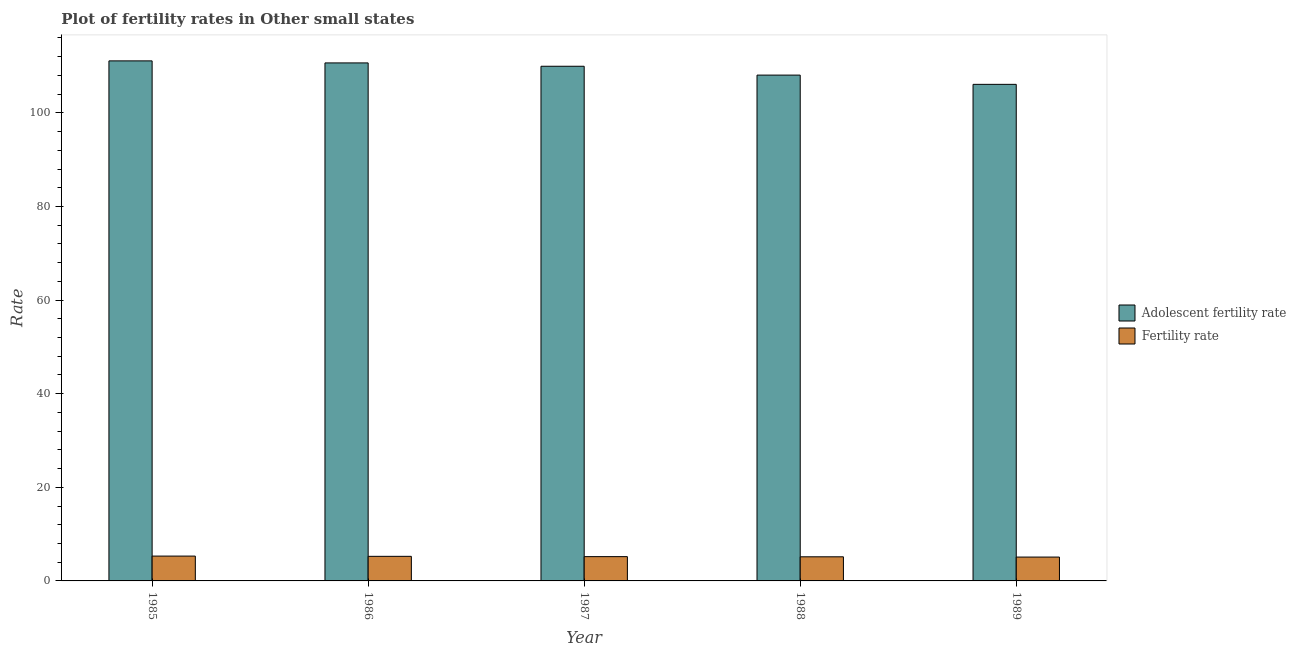How many different coloured bars are there?
Provide a succinct answer. 2. How many groups of bars are there?
Your response must be concise. 5. Are the number of bars on each tick of the X-axis equal?
Give a very brief answer. Yes. What is the label of the 1st group of bars from the left?
Your answer should be very brief. 1985. In how many cases, is the number of bars for a given year not equal to the number of legend labels?
Give a very brief answer. 0. What is the fertility rate in 1987?
Offer a very short reply. 5.19. Across all years, what is the maximum fertility rate?
Give a very brief answer. 5.3. Across all years, what is the minimum adolescent fertility rate?
Keep it short and to the point. 106.08. What is the total adolescent fertility rate in the graph?
Your answer should be very brief. 545.86. What is the difference between the fertility rate in 1986 and that in 1987?
Provide a succinct answer. 0.06. What is the difference between the fertility rate in 1988 and the adolescent fertility rate in 1989?
Ensure brevity in your answer.  0.06. What is the average adolescent fertility rate per year?
Provide a short and direct response. 109.17. In how many years, is the adolescent fertility rate greater than 60?
Keep it short and to the point. 5. What is the ratio of the fertility rate in 1987 to that in 1989?
Provide a succinct answer. 1.02. Is the adolescent fertility rate in 1987 less than that in 1988?
Offer a terse response. No. Is the difference between the fertility rate in 1986 and 1987 greater than the difference between the adolescent fertility rate in 1986 and 1987?
Make the answer very short. No. What is the difference between the highest and the second highest adolescent fertility rate?
Your answer should be very brief. 0.44. What is the difference between the highest and the lowest adolescent fertility rate?
Offer a very short reply. 5.02. In how many years, is the fertility rate greater than the average fertility rate taken over all years?
Offer a terse response. 2. Is the sum of the fertility rate in 1987 and 1988 greater than the maximum adolescent fertility rate across all years?
Provide a short and direct response. Yes. What does the 1st bar from the left in 1988 represents?
Keep it short and to the point. Adolescent fertility rate. What does the 1st bar from the right in 1988 represents?
Give a very brief answer. Fertility rate. How many bars are there?
Ensure brevity in your answer.  10. What is the difference between two consecutive major ticks on the Y-axis?
Offer a terse response. 20. Are the values on the major ticks of Y-axis written in scientific E-notation?
Your answer should be compact. No. What is the title of the graph?
Keep it short and to the point. Plot of fertility rates in Other small states. What is the label or title of the X-axis?
Keep it short and to the point. Year. What is the label or title of the Y-axis?
Give a very brief answer. Rate. What is the Rate of Adolescent fertility rate in 1985?
Your response must be concise. 111.1. What is the Rate of Fertility rate in 1985?
Ensure brevity in your answer.  5.3. What is the Rate of Adolescent fertility rate in 1986?
Make the answer very short. 110.66. What is the Rate of Fertility rate in 1986?
Your answer should be compact. 5.25. What is the Rate in Adolescent fertility rate in 1987?
Your answer should be compact. 109.95. What is the Rate in Fertility rate in 1987?
Offer a very short reply. 5.19. What is the Rate in Adolescent fertility rate in 1988?
Provide a succinct answer. 108.06. What is the Rate in Fertility rate in 1988?
Keep it short and to the point. 5.15. What is the Rate of Adolescent fertility rate in 1989?
Provide a short and direct response. 106.08. What is the Rate in Fertility rate in 1989?
Offer a very short reply. 5.1. Across all years, what is the maximum Rate in Adolescent fertility rate?
Ensure brevity in your answer.  111.1. Across all years, what is the maximum Rate in Fertility rate?
Provide a succinct answer. 5.3. Across all years, what is the minimum Rate in Adolescent fertility rate?
Offer a very short reply. 106.08. Across all years, what is the minimum Rate of Fertility rate?
Make the answer very short. 5.1. What is the total Rate of Adolescent fertility rate in the graph?
Keep it short and to the point. 545.86. What is the total Rate of Fertility rate in the graph?
Your response must be concise. 25.99. What is the difference between the Rate of Adolescent fertility rate in 1985 and that in 1986?
Ensure brevity in your answer.  0.44. What is the difference between the Rate in Fertility rate in 1985 and that in 1986?
Give a very brief answer. 0.05. What is the difference between the Rate of Adolescent fertility rate in 1985 and that in 1987?
Provide a succinct answer. 1.15. What is the difference between the Rate in Fertility rate in 1985 and that in 1987?
Offer a very short reply. 0.11. What is the difference between the Rate of Adolescent fertility rate in 1985 and that in 1988?
Give a very brief answer. 3.04. What is the difference between the Rate in Fertility rate in 1985 and that in 1988?
Make the answer very short. 0.15. What is the difference between the Rate in Adolescent fertility rate in 1985 and that in 1989?
Offer a very short reply. 5.02. What is the difference between the Rate of Fertility rate in 1985 and that in 1989?
Your response must be concise. 0.21. What is the difference between the Rate in Adolescent fertility rate in 1986 and that in 1987?
Give a very brief answer. 0.71. What is the difference between the Rate in Fertility rate in 1986 and that in 1987?
Keep it short and to the point. 0.06. What is the difference between the Rate of Adolescent fertility rate in 1986 and that in 1988?
Your response must be concise. 2.6. What is the difference between the Rate in Fertility rate in 1986 and that in 1988?
Make the answer very short. 0.1. What is the difference between the Rate in Adolescent fertility rate in 1986 and that in 1989?
Ensure brevity in your answer.  4.58. What is the difference between the Rate in Fertility rate in 1986 and that in 1989?
Your answer should be compact. 0.16. What is the difference between the Rate of Adolescent fertility rate in 1987 and that in 1988?
Keep it short and to the point. 1.89. What is the difference between the Rate in Fertility rate in 1987 and that in 1988?
Your answer should be compact. 0.04. What is the difference between the Rate in Adolescent fertility rate in 1987 and that in 1989?
Ensure brevity in your answer.  3.87. What is the difference between the Rate of Fertility rate in 1987 and that in 1989?
Give a very brief answer. 0.09. What is the difference between the Rate in Adolescent fertility rate in 1988 and that in 1989?
Offer a very short reply. 1.98. What is the difference between the Rate of Fertility rate in 1988 and that in 1989?
Your answer should be compact. 0.06. What is the difference between the Rate in Adolescent fertility rate in 1985 and the Rate in Fertility rate in 1986?
Offer a very short reply. 105.85. What is the difference between the Rate in Adolescent fertility rate in 1985 and the Rate in Fertility rate in 1987?
Your response must be concise. 105.91. What is the difference between the Rate in Adolescent fertility rate in 1985 and the Rate in Fertility rate in 1988?
Ensure brevity in your answer.  105.95. What is the difference between the Rate in Adolescent fertility rate in 1985 and the Rate in Fertility rate in 1989?
Provide a succinct answer. 106. What is the difference between the Rate of Adolescent fertility rate in 1986 and the Rate of Fertility rate in 1987?
Your answer should be compact. 105.47. What is the difference between the Rate in Adolescent fertility rate in 1986 and the Rate in Fertility rate in 1988?
Your answer should be compact. 105.51. What is the difference between the Rate of Adolescent fertility rate in 1986 and the Rate of Fertility rate in 1989?
Give a very brief answer. 105.57. What is the difference between the Rate in Adolescent fertility rate in 1987 and the Rate in Fertility rate in 1988?
Provide a short and direct response. 104.8. What is the difference between the Rate in Adolescent fertility rate in 1987 and the Rate in Fertility rate in 1989?
Offer a terse response. 104.86. What is the difference between the Rate in Adolescent fertility rate in 1988 and the Rate in Fertility rate in 1989?
Your response must be concise. 102.97. What is the average Rate of Adolescent fertility rate per year?
Ensure brevity in your answer.  109.17. What is the average Rate of Fertility rate per year?
Offer a very short reply. 5.2. In the year 1985, what is the difference between the Rate in Adolescent fertility rate and Rate in Fertility rate?
Offer a terse response. 105.8. In the year 1986, what is the difference between the Rate of Adolescent fertility rate and Rate of Fertility rate?
Your response must be concise. 105.41. In the year 1987, what is the difference between the Rate in Adolescent fertility rate and Rate in Fertility rate?
Give a very brief answer. 104.76. In the year 1988, what is the difference between the Rate of Adolescent fertility rate and Rate of Fertility rate?
Make the answer very short. 102.91. In the year 1989, what is the difference between the Rate of Adolescent fertility rate and Rate of Fertility rate?
Ensure brevity in your answer.  100.99. What is the ratio of the Rate in Fertility rate in 1985 to that in 1986?
Your answer should be compact. 1.01. What is the ratio of the Rate of Adolescent fertility rate in 1985 to that in 1987?
Make the answer very short. 1.01. What is the ratio of the Rate in Fertility rate in 1985 to that in 1987?
Give a very brief answer. 1.02. What is the ratio of the Rate in Adolescent fertility rate in 1985 to that in 1988?
Make the answer very short. 1.03. What is the ratio of the Rate of Fertility rate in 1985 to that in 1988?
Give a very brief answer. 1.03. What is the ratio of the Rate in Adolescent fertility rate in 1985 to that in 1989?
Offer a terse response. 1.05. What is the ratio of the Rate in Fertility rate in 1985 to that in 1989?
Make the answer very short. 1.04. What is the ratio of the Rate in Adolescent fertility rate in 1986 to that in 1987?
Your answer should be very brief. 1.01. What is the ratio of the Rate of Adolescent fertility rate in 1986 to that in 1988?
Provide a short and direct response. 1.02. What is the ratio of the Rate of Fertility rate in 1986 to that in 1988?
Your response must be concise. 1.02. What is the ratio of the Rate in Adolescent fertility rate in 1986 to that in 1989?
Give a very brief answer. 1.04. What is the ratio of the Rate of Fertility rate in 1986 to that in 1989?
Make the answer very short. 1.03. What is the ratio of the Rate in Adolescent fertility rate in 1987 to that in 1988?
Make the answer very short. 1.02. What is the ratio of the Rate of Fertility rate in 1987 to that in 1988?
Your response must be concise. 1.01. What is the ratio of the Rate of Adolescent fertility rate in 1987 to that in 1989?
Give a very brief answer. 1.04. What is the ratio of the Rate of Fertility rate in 1987 to that in 1989?
Make the answer very short. 1.02. What is the ratio of the Rate in Adolescent fertility rate in 1988 to that in 1989?
Offer a terse response. 1.02. What is the ratio of the Rate in Fertility rate in 1988 to that in 1989?
Provide a succinct answer. 1.01. What is the difference between the highest and the second highest Rate of Adolescent fertility rate?
Provide a short and direct response. 0.44. What is the difference between the highest and the second highest Rate in Fertility rate?
Make the answer very short. 0.05. What is the difference between the highest and the lowest Rate in Adolescent fertility rate?
Keep it short and to the point. 5.02. What is the difference between the highest and the lowest Rate in Fertility rate?
Your response must be concise. 0.21. 